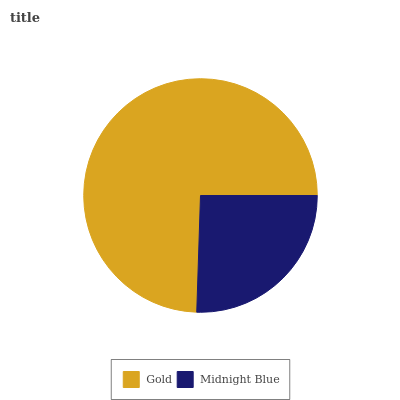Is Midnight Blue the minimum?
Answer yes or no. Yes. Is Gold the maximum?
Answer yes or no. Yes. Is Midnight Blue the maximum?
Answer yes or no. No. Is Gold greater than Midnight Blue?
Answer yes or no. Yes. Is Midnight Blue less than Gold?
Answer yes or no. Yes. Is Midnight Blue greater than Gold?
Answer yes or no. No. Is Gold less than Midnight Blue?
Answer yes or no. No. Is Gold the high median?
Answer yes or no. Yes. Is Midnight Blue the low median?
Answer yes or no. Yes. Is Midnight Blue the high median?
Answer yes or no. No. Is Gold the low median?
Answer yes or no. No. 